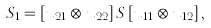Convert formula to latex. <formula><loc_0><loc_0><loc_500><loc_500>S _ { 1 } = \left [ u _ { 2 1 } \otimes u _ { 2 2 } \right ] S \left [ u _ { 1 1 } \otimes u _ { 1 2 } \right ] ,</formula> 